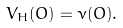<formula> <loc_0><loc_0><loc_500><loc_500>V _ { H } ( O ) = \nu ( O ) .</formula> 